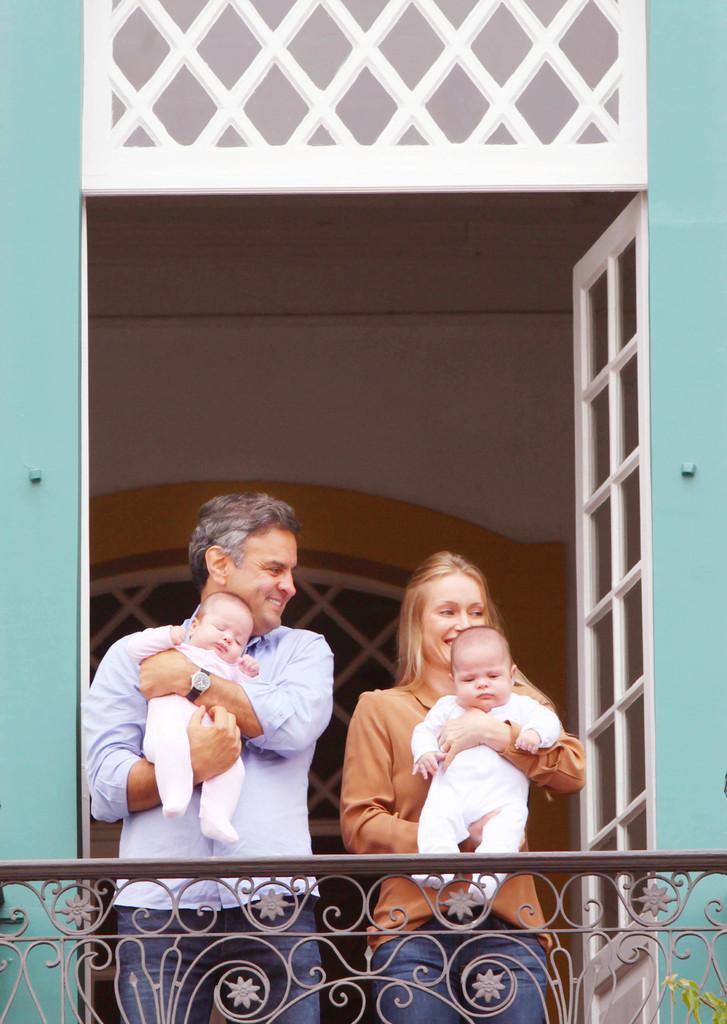Describe this image in one or two sentences. In this image, we can see a woman and man are carrying babies and smiling. At the bottom, we can see railing. Here we can see walls, door and glass object. 